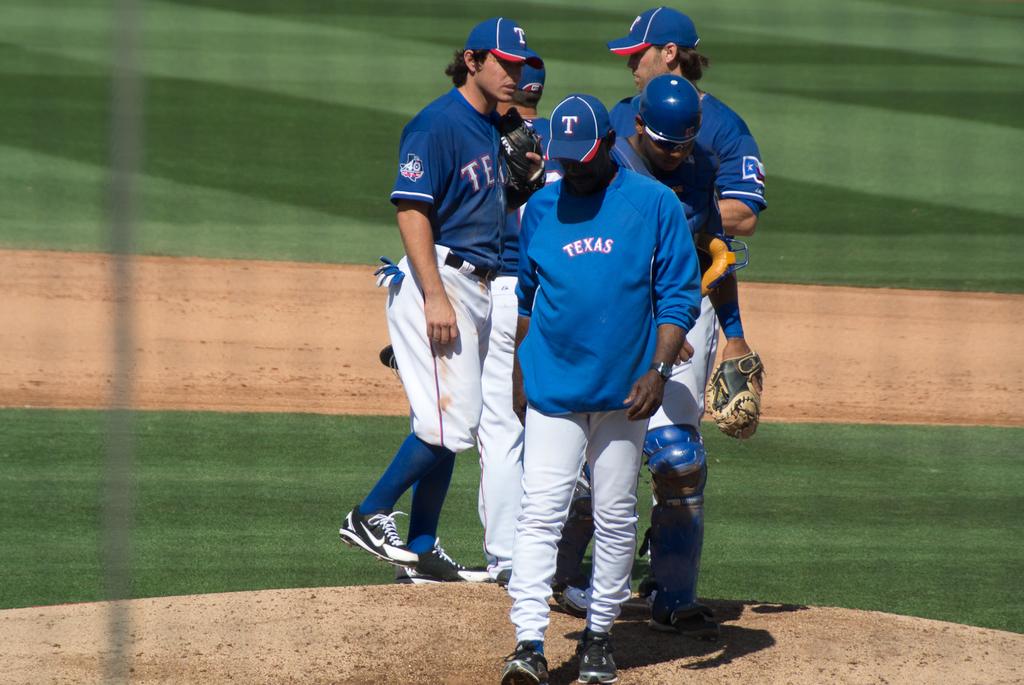What baseball team is playing?
Provide a short and direct response. Texas. 